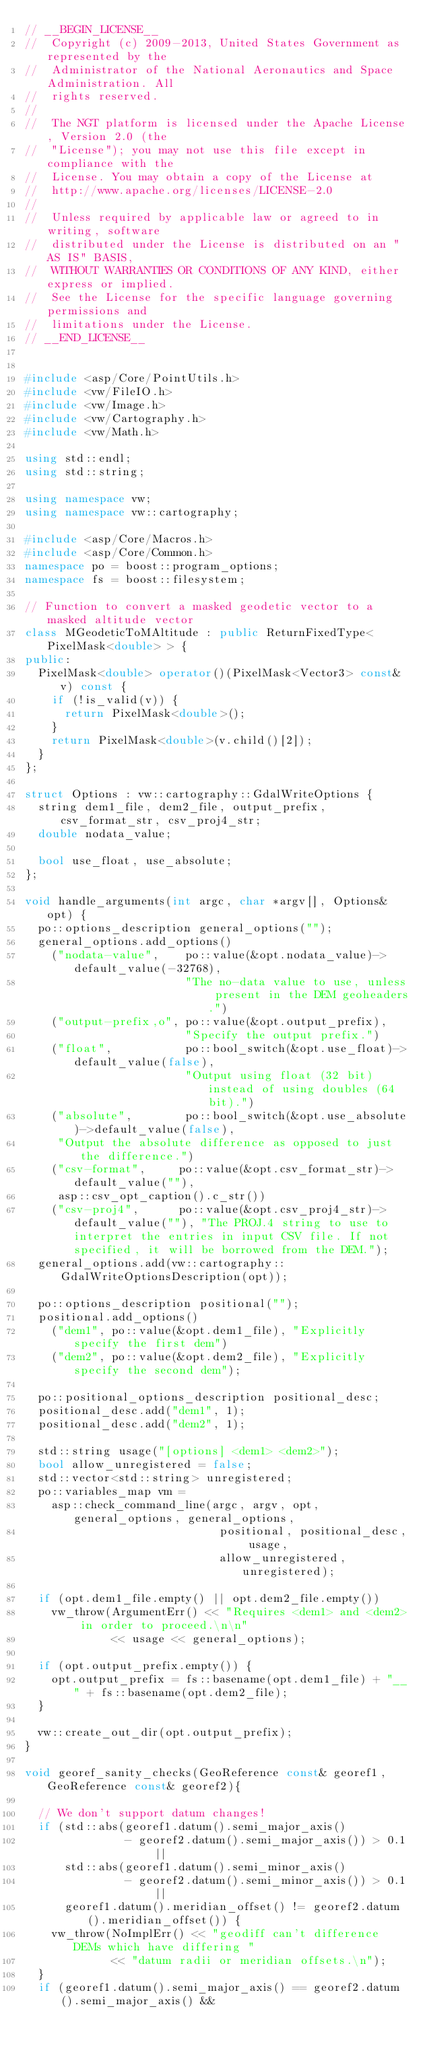<code> <loc_0><loc_0><loc_500><loc_500><_C++_>// __BEGIN_LICENSE__
//  Copyright (c) 2009-2013, United States Government as represented by the
//  Administrator of the National Aeronautics and Space Administration. All
//  rights reserved.
//
//  The NGT platform is licensed under the Apache License, Version 2.0 (the
//  "License"); you may not use this file except in compliance with the
//  License. You may obtain a copy of the License at
//  http://www.apache.org/licenses/LICENSE-2.0
//
//  Unless required by applicable law or agreed to in writing, software
//  distributed under the License is distributed on an "AS IS" BASIS,
//  WITHOUT WARRANTIES OR CONDITIONS OF ANY KIND, either express or implied.
//  See the License for the specific language governing permissions and
//  limitations under the License.
// __END_LICENSE__


#include <asp/Core/PointUtils.h>
#include <vw/FileIO.h>
#include <vw/Image.h>
#include <vw/Cartography.h>
#include <vw/Math.h>

using std::endl;
using std::string;

using namespace vw;
using namespace vw::cartography;

#include <asp/Core/Macros.h>
#include <asp/Core/Common.h>
namespace po = boost::program_options;
namespace fs = boost::filesystem;

// Function to convert a masked geodetic vector to a masked altitude vector
class MGeodeticToMAltitude : public ReturnFixedType<PixelMask<double> > {
public:
  PixelMask<double> operator()(PixelMask<Vector3> const& v) const {
    if (!is_valid(v)) {
      return PixelMask<double>();
    }
    return PixelMask<double>(v.child()[2]);
  }
};

struct Options : vw::cartography::GdalWriteOptions {
  string dem1_file, dem2_file, output_prefix, csv_format_str, csv_proj4_str;
  double nodata_value;

  bool use_float, use_absolute;
};

void handle_arguments(int argc, char *argv[], Options& opt) {
  po::options_description general_options("");
  general_options.add_options()
    ("nodata-value",    po::value(&opt.nodata_value)->default_value(-32768),      
                        "The no-data value to use, unless present in the DEM geoheaders.")
    ("output-prefix,o", po::value(&opt.output_prefix),                            
                        "Specify the output prefix.")
    ("float",           po::bool_switch(&opt.use_float)->default_value(false),    
                        "Output using float (32 bit) instead of using doubles (64 bit).")
    ("absolute",        po::bool_switch(&opt.use_absolute)->default_value(false), 
     "Output the absolute difference as opposed to just the difference.")
    ("csv-format",     po::value(&opt.csv_format_str)->default_value(""),
     asp::csv_opt_caption().c_str())
    ("csv-proj4",      po::value(&opt.csv_proj4_str)->default_value(""), "The PROJ.4 string to use to interpret the entries in input CSV file. If not specified, it will be borrowed from the DEM.");
  general_options.add(vw::cartography::GdalWriteOptionsDescription(opt));

  po::options_description positional("");
  positional.add_options()
    ("dem1", po::value(&opt.dem1_file), "Explicitly specify the first dem")
    ("dem2", po::value(&opt.dem2_file), "Explicitly specify the second dem");

  po::positional_options_description positional_desc;
  positional_desc.add("dem1", 1);
  positional_desc.add("dem2", 1);

  std::string usage("[options] <dem1> <dem2>");
  bool allow_unregistered = false;
  std::vector<std::string> unregistered;
  po::variables_map vm =
    asp::check_command_line(argc, argv, opt, general_options, general_options,
                             positional, positional_desc, usage,
                             allow_unregistered, unregistered);

  if (opt.dem1_file.empty() || opt.dem2_file.empty())
    vw_throw(ArgumentErr() << "Requires <dem1> and <dem2> in order to proceed.\n\n"
             << usage << general_options);

  if (opt.output_prefix.empty()) {
    opt.output_prefix = fs::basename(opt.dem1_file) + "__" + fs::basename(opt.dem2_file);
  }

  vw::create_out_dir(opt.output_prefix);
}

void georef_sanity_checks(GeoReference const& georef1, GeoReference const& georef2){

  // We don't support datum changes!
  if (std::abs(georef1.datum().semi_major_axis()
               - georef2.datum().semi_major_axis()) > 0.1 ||
      std::abs(georef1.datum().semi_minor_axis()
               - georef2.datum().semi_minor_axis()) > 0.1 ||
      georef1.datum().meridian_offset() != georef2.datum().meridian_offset()) {
    vw_throw(NoImplErr() << "geodiff can't difference DEMs which have differing "
             << "datum radii or meridian offsets.\n");
  }
  if (georef1.datum().semi_major_axis() == georef2.datum().semi_major_axis() &&</code> 